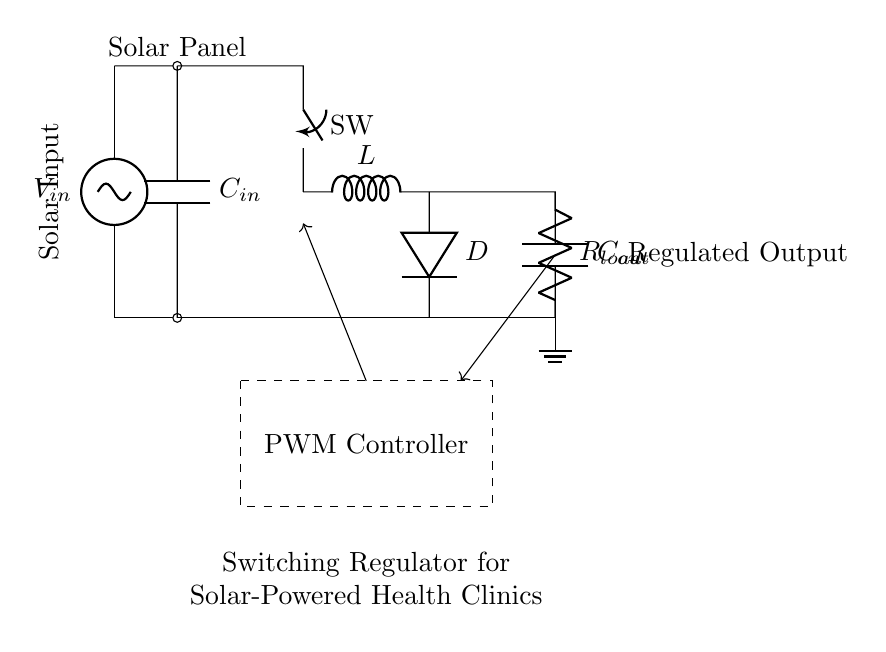What component regulates the output voltage? The component that regulates the output voltage is the PWM controller, which adjusts the switching of the power through the inductor and diode to maintain a steady voltage output.
Answer: PWM controller What is the role of the inductor in this circuit? The inductor stores energy when the switch is closed and releases it to the load when the switch is opened, thereby converting voltage and contributing to the regulation process.
Answer: Energy storage What type of switch is used in this circuit? The switch used in this circuit is a closing switch, which toggles between open and closed states to control the flow of energy into the inductor.
Answer: Closing switch What is the function of the output capacitor? The output capacitor smooths the output voltage by reducing voltage ripple at the output, ensuring a stable power supply for the load.
Answer: Smoothing voltage How does feedback work in this regulator circuit? Feedback in this circuit monitors the output voltage and sends a signal back to the PWM controller, helping it adjust the switching frequency to maintain the desired output level.
Answer: Monitors output voltage What happens to excess solar energy in this circuit? Excess solar energy is managed by the PWM controller which regulates the energy sent to the load, preventing overflow while ensuring optimal power usage for the clinic.
Answer: Managed by PWM 